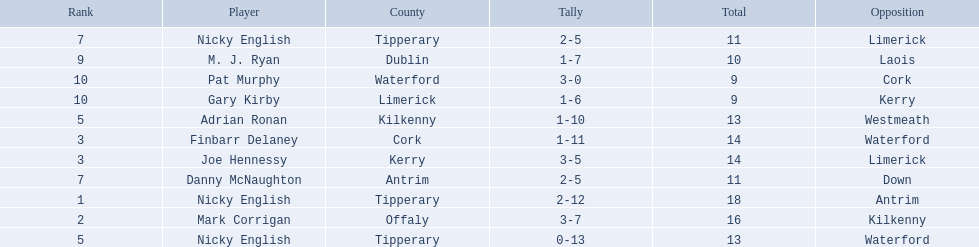What numbers are in the total column? 18, 16, 14, 14, 13, 13, 11, 11, 10, 9, 9. What row has the number 10 in the total column? 9, M. J. Ryan, Dublin, 1-7, 10, Laois. What name is in the player column for this row? M. J. Ryan. 